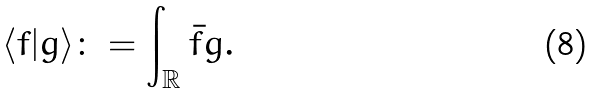<formula> <loc_0><loc_0><loc_500><loc_500>\langle f | g \rangle \colon = \int _ { \mathbb { R } } \bar { f } g .</formula> 